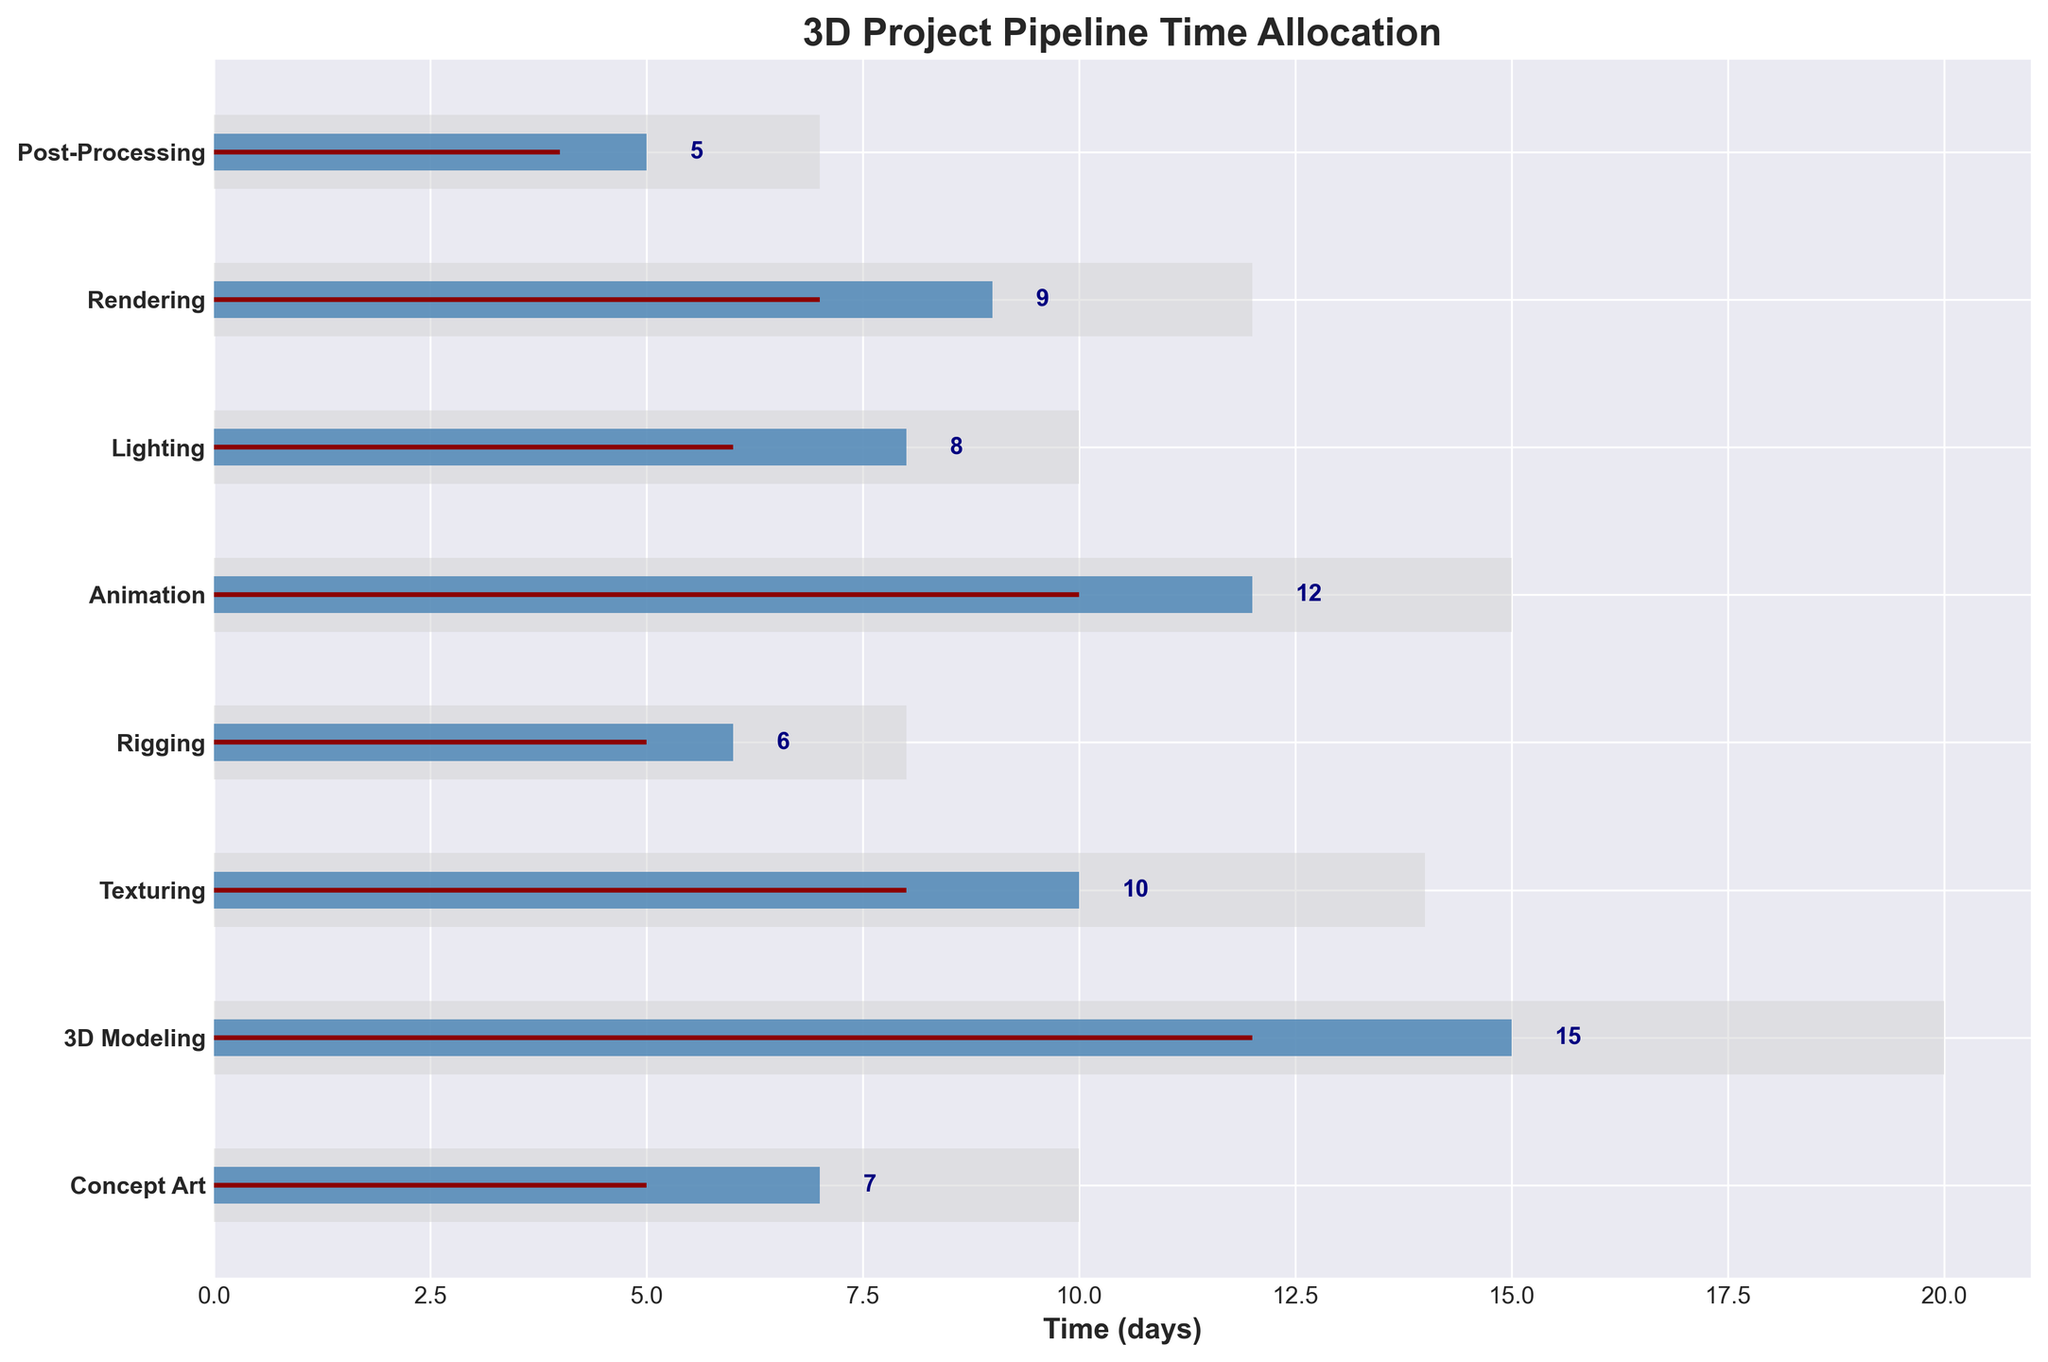What is the title of the chart? The title is typically found at the top of the chart, indicating the main subject. In this case, it reads "3D Project Pipeline Time Allocation".
Answer: 3D Project Pipeline Time Allocation How many stages are displayed in the chart? Count the number of unique stages listed along the y-axis. There are 8 stages in total.
Answer: 8 Which stage exceeded its target by the largest number of days? To find this, subtract the target values from the actual values for each stage and identify the largest difference. "3D Modeling" has (15 - 12) = 3 days, which is the largest difference.
Answer: 3D Modeling What stage has the closest actual time to its target time? Calculate the difference between actual and target times for each stage and find the smallest difference. "Rigging" has the closest actual time, with (6 - 5) = 1 day.
Answer: Rigging How does the actual time for Animation compare to its target and maximum time? Check the values for Animation: actual is 12 days, target is 10 days, and maximum is 15 days. Animation exceeds its target by 2 days and is 3 days below the maximum.
Answer: Exceeds target by 2 days, 3 days below maximum What is the total actual time spent on all stages combined? Sum all the actual time values: 7 + 15 + 10 + 6 + 12 + 8 + 9 + 5 = 72 days.
Answer: 72 days Which stage has the least difference between actual and maximum times? Subtract the actual time from the maximum time for each stage and find the smallest difference. Rigging has the least difference, with (8 - 6) = 2 days.
Answer: Rigging Are there any stages where actual time is less than the target time? Compare actual and target times for each stage to check if any actual time is less. Here, no stage has an actual time less than its target time.
Answer: No Which stage has the highest actual time? Identify the stage with the highest value in the actual time category. "3D Modeling" has the highest actual time at 15 days.
Answer: 3D Modeling What is the average target time across all stages? Sum all target times and divide by the number of stages: (5 + 12 + 8 + 5 + 10 + 6 + 7 + 4) / 8. This gives 57 / 8 = 7.125 days.
Answer: 7.125 days 